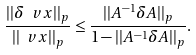<formula> <loc_0><loc_0><loc_500><loc_500>\frac { | | \delta \ v x | | _ { p } } { | | \ v x | | _ { p } } \leq \frac { | | A ^ { - 1 } \delta A | | _ { p } } { 1 - | | A ^ { - 1 } \delta A | | _ { p } } .</formula> 